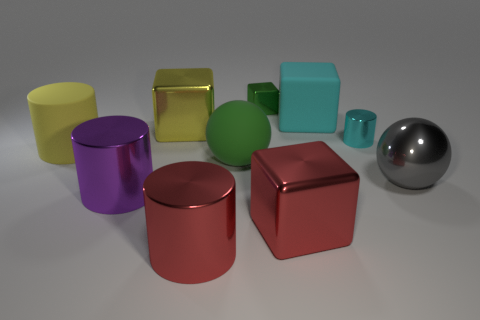Subtract all purple metallic cylinders. How many cylinders are left? 3 Subtract all yellow cylinders. How many cylinders are left? 3 Subtract all cubes. How many objects are left? 6 Subtract all purple cubes. Subtract all red spheres. How many cubes are left? 4 Add 6 green balls. How many green balls exist? 7 Subtract 0 brown spheres. How many objects are left? 10 Subtract all green cubes. Subtract all big shiny cylinders. How many objects are left? 7 Add 9 gray metal spheres. How many gray metal spheres are left? 10 